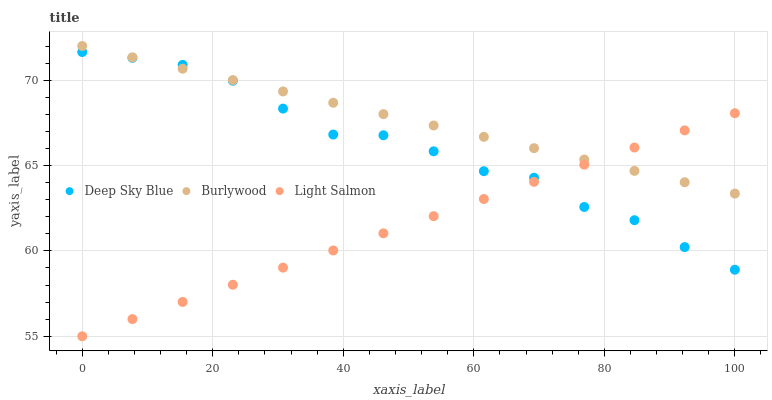Does Light Salmon have the minimum area under the curve?
Answer yes or no. Yes. Does Burlywood have the maximum area under the curve?
Answer yes or no. Yes. Does Deep Sky Blue have the minimum area under the curve?
Answer yes or no. No. Does Deep Sky Blue have the maximum area under the curve?
Answer yes or no. No. Is Light Salmon the smoothest?
Answer yes or no. Yes. Is Deep Sky Blue the roughest?
Answer yes or no. Yes. Is Deep Sky Blue the smoothest?
Answer yes or no. No. Is Light Salmon the roughest?
Answer yes or no. No. Does Light Salmon have the lowest value?
Answer yes or no. Yes. Does Deep Sky Blue have the lowest value?
Answer yes or no. No. Does Burlywood have the highest value?
Answer yes or no. Yes. Does Deep Sky Blue have the highest value?
Answer yes or no. No. Does Light Salmon intersect Burlywood?
Answer yes or no. Yes. Is Light Salmon less than Burlywood?
Answer yes or no. No. Is Light Salmon greater than Burlywood?
Answer yes or no. No. 